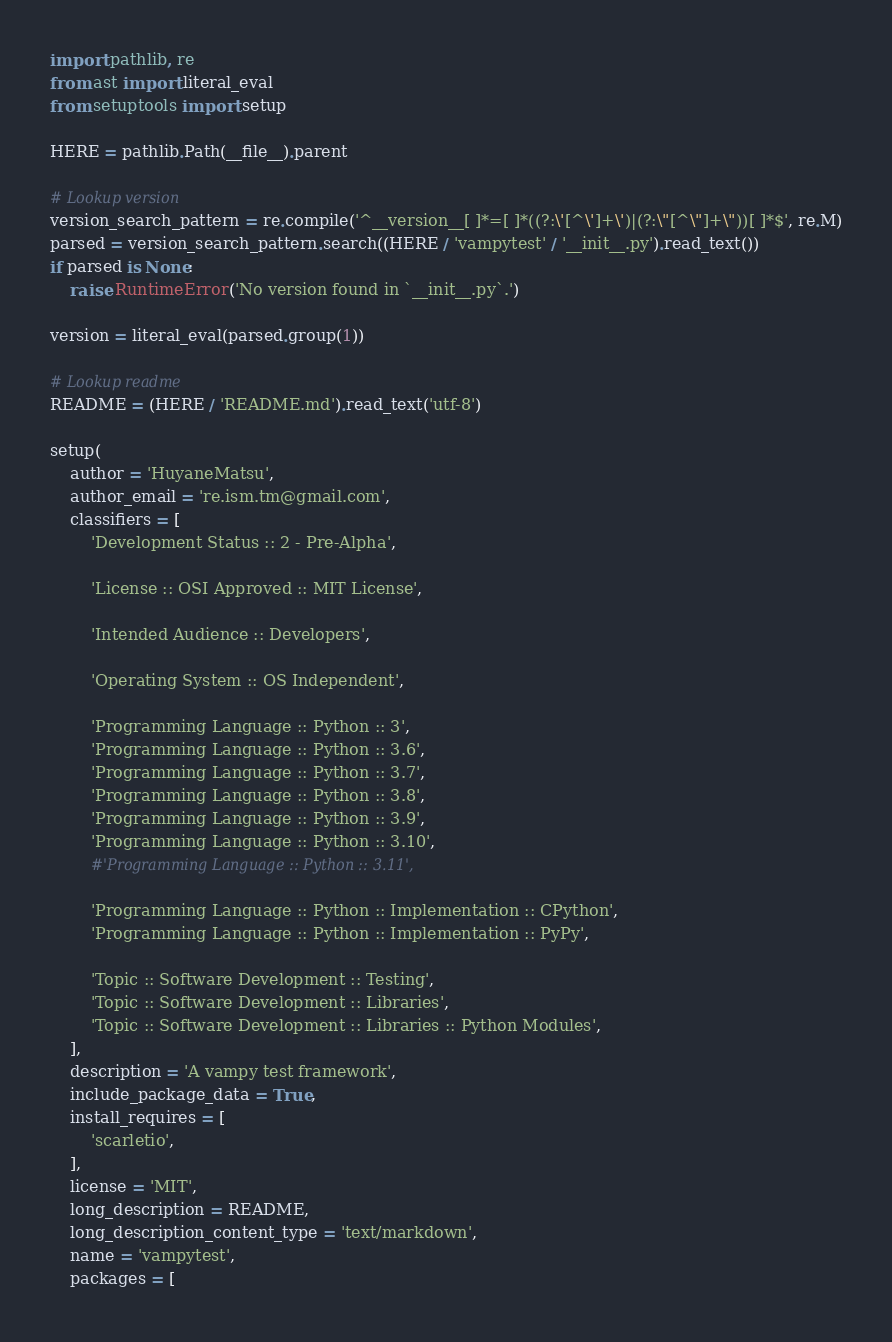Convert code to text. <code><loc_0><loc_0><loc_500><loc_500><_Python_>import pathlib, re
from ast import literal_eval
from setuptools import setup

HERE = pathlib.Path(__file__).parent

# Lookup version
version_search_pattern = re.compile('^__version__[ ]*=[ ]*((?:\'[^\']+\')|(?:\"[^\"]+\"))[ ]*$', re.M)
parsed = version_search_pattern.search((HERE / 'vampytest' / '__init__.py').read_text())
if parsed is None:
    raise RuntimeError('No version found in `__init__.py`.')

version = literal_eval(parsed.group(1))

# Lookup readme
README = (HERE / 'README.md').read_text('utf-8')

setup(
    author = 'HuyaneMatsu',
    author_email = 're.ism.tm@gmail.com',
    classifiers = [
        'Development Status :: 2 - Pre-Alpha',

        'License :: OSI Approved :: MIT License',

        'Intended Audience :: Developers',

        'Operating System :: OS Independent',

        'Programming Language :: Python :: 3',
        'Programming Language :: Python :: 3.6',
        'Programming Language :: Python :: 3.7',
        'Programming Language :: Python :: 3.8',
        'Programming Language :: Python :: 3.9',
        'Programming Language :: Python :: 3.10',
        #'Programming Language :: Python :: 3.11',
        
        'Programming Language :: Python :: Implementation :: CPython',
        'Programming Language :: Python :: Implementation :: PyPy',
        
        'Topic :: Software Development :: Testing',
        'Topic :: Software Development :: Libraries',
        'Topic :: Software Development :: Libraries :: Python Modules',
    ],
    description = 'A vampy test framework',
    include_package_data = True,
    install_requires = [
        'scarletio',
    ],
    license = 'MIT',
    long_description = README,
    long_description_content_type = 'text/markdown',
    name = 'vampytest',
    packages = [</code> 